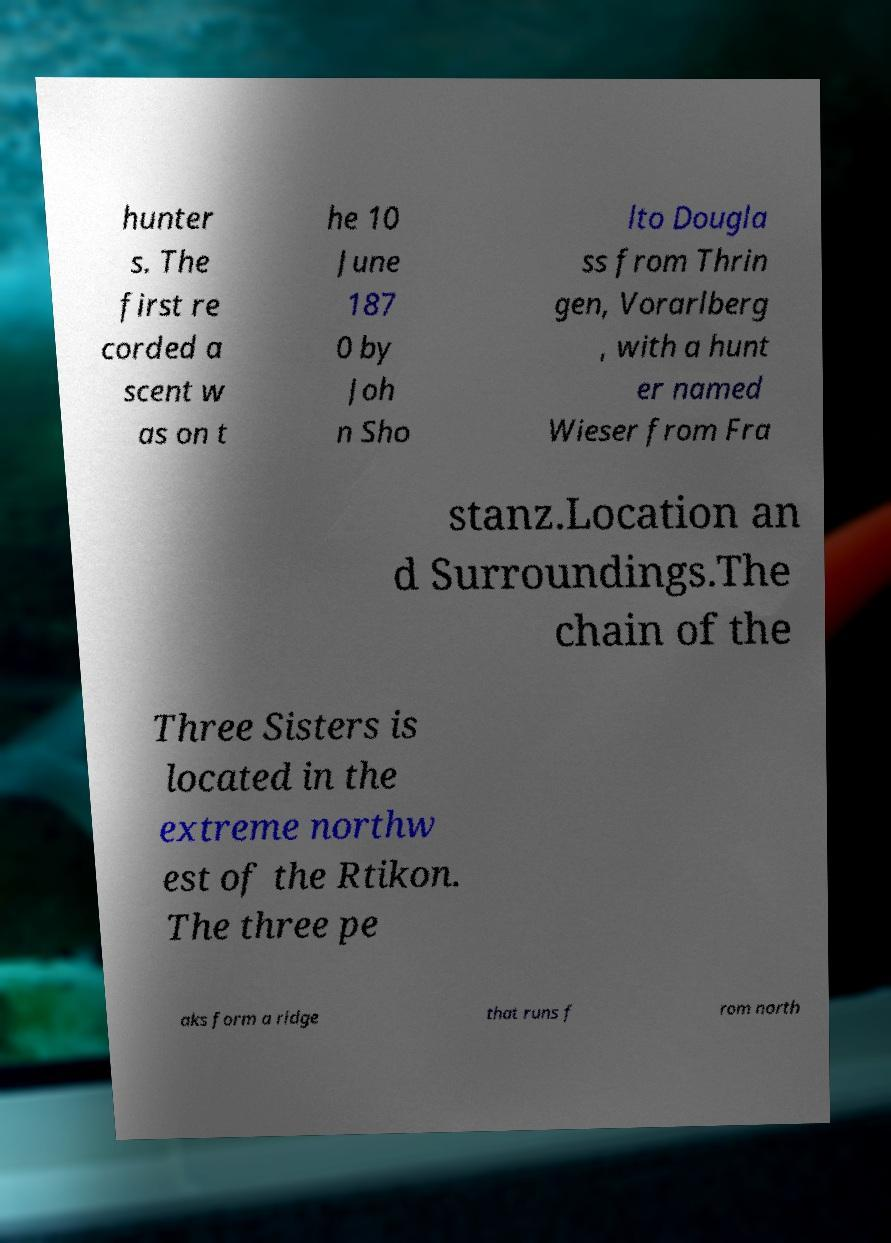There's text embedded in this image that I need extracted. Can you transcribe it verbatim? hunter s. The first re corded a scent w as on t he 10 June 187 0 by Joh n Sho lto Dougla ss from Thrin gen, Vorarlberg , with a hunt er named Wieser from Fra stanz.Location an d Surroundings.The chain of the Three Sisters is located in the extreme northw est of the Rtikon. The three pe aks form a ridge that runs f rom north 